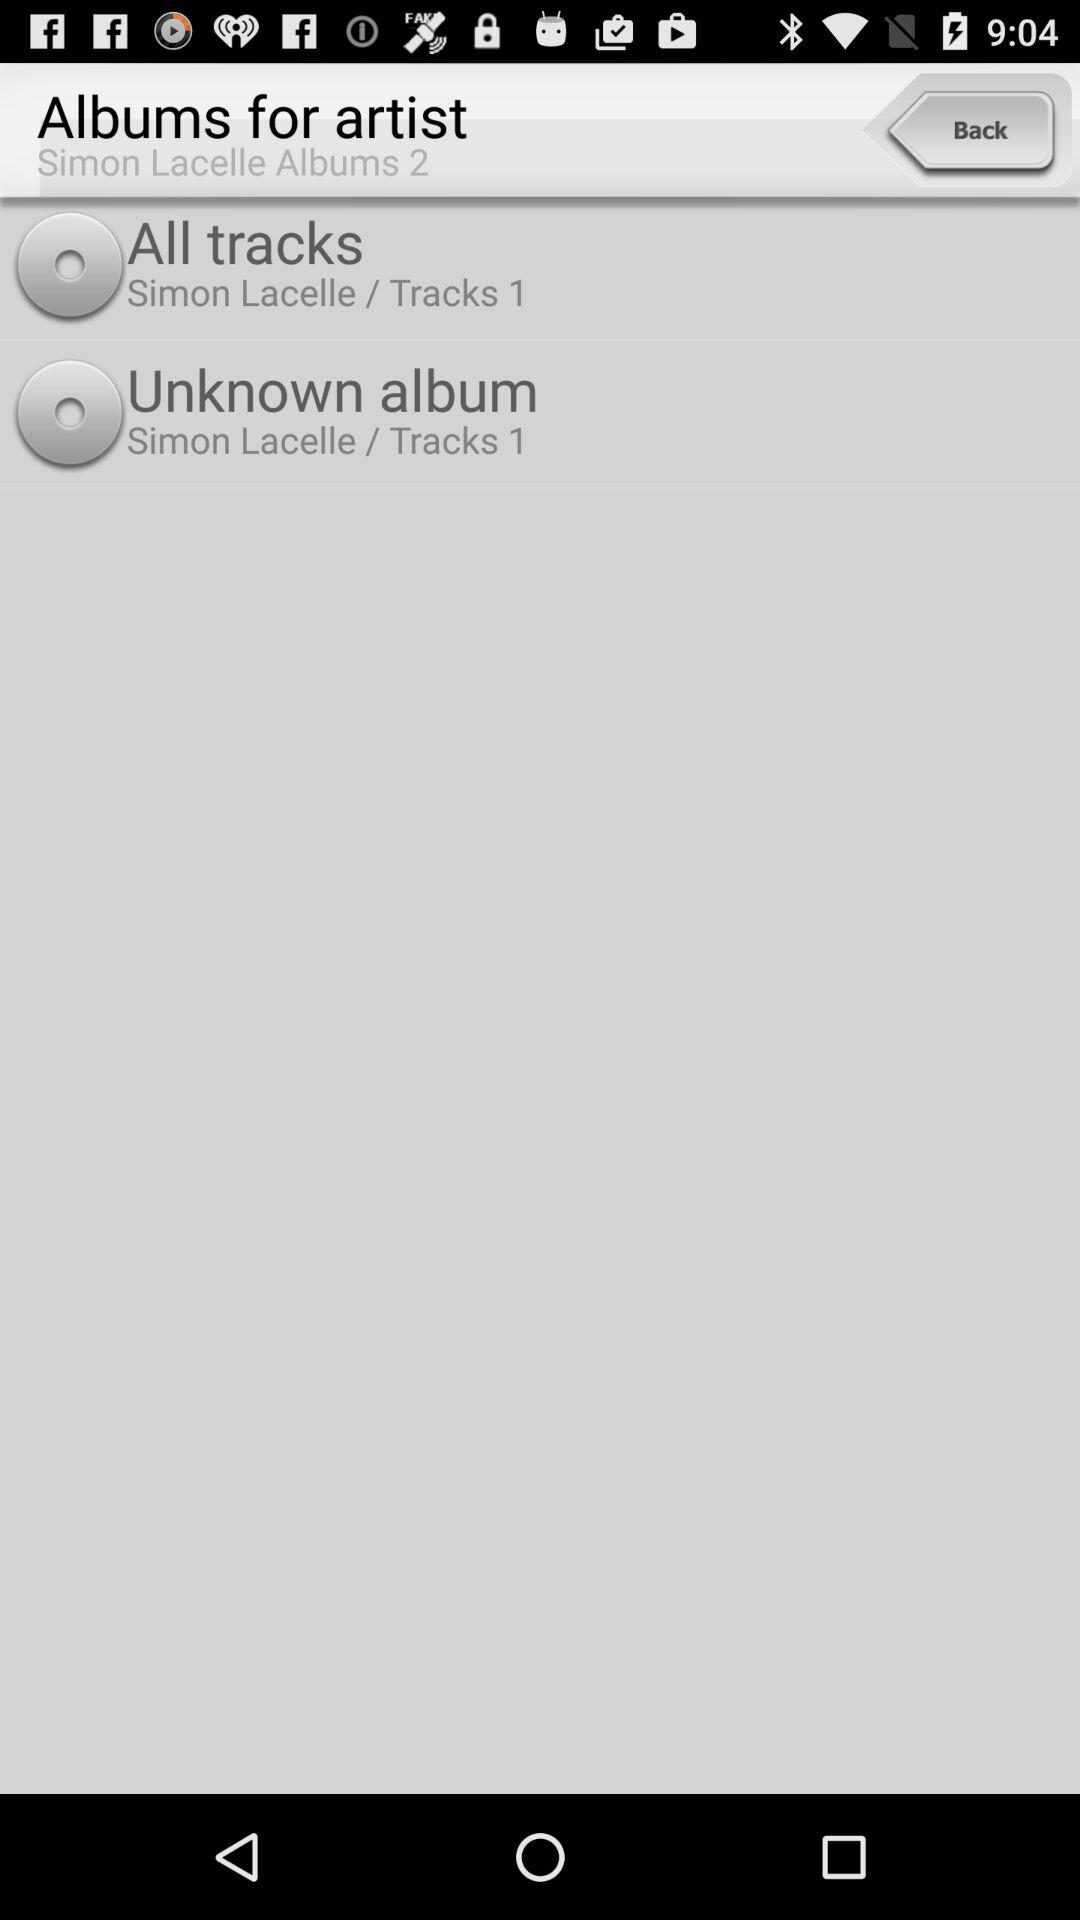How many tracks are available for the album Unknown album?
Answer the question using a single word or phrase. 1 